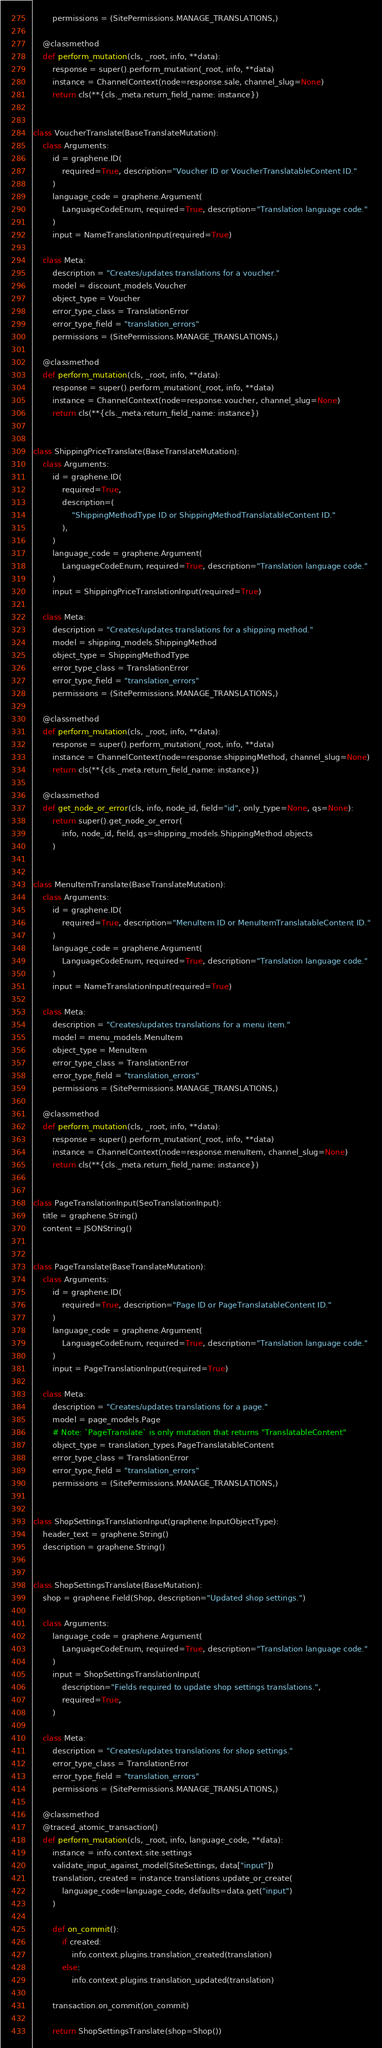Convert code to text. <code><loc_0><loc_0><loc_500><loc_500><_Python_>        permissions = (SitePermissions.MANAGE_TRANSLATIONS,)

    @classmethod
    def perform_mutation(cls, _root, info, **data):
        response = super().perform_mutation(_root, info, **data)
        instance = ChannelContext(node=response.sale, channel_slug=None)
        return cls(**{cls._meta.return_field_name: instance})


class VoucherTranslate(BaseTranslateMutation):
    class Arguments:
        id = graphene.ID(
            required=True, description="Voucher ID or VoucherTranslatableContent ID."
        )
        language_code = graphene.Argument(
            LanguageCodeEnum, required=True, description="Translation language code."
        )
        input = NameTranslationInput(required=True)

    class Meta:
        description = "Creates/updates translations for a voucher."
        model = discount_models.Voucher
        object_type = Voucher
        error_type_class = TranslationError
        error_type_field = "translation_errors"
        permissions = (SitePermissions.MANAGE_TRANSLATIONS,)

    @classmethod
    def perform_mutation(cls, _root, info, **data):
        response = super().perform_mutation(_root, info, **data)
        instance = ChannelContext(node=response.voucher, channel_slug=None)
        return cls(**{cls._meta.return_field_name: instance})


class ShippingPriceTranslate(BaseTranslateMutation):
    class Arguments:
        id = graphene.ID(
            required=True,
            description=(
                "ShippingMethodType ID or ShippingMethodTranslatableContent ID."
            ),
        )
        language_code = graphene.Argument(
            LanguageCodeEnum, required=True, description="Translation language code."
        )
        input = ShippingPriceTranslationInput(required=True)

    class Meta:
        description = "Creates/updates translations for a shipping method."
        model = shipping_models.ShippingMethod
        object_type = ShippingMethodType
        error_type_class = TranslationError
        error_type_field = "translation_errors"
        permissions = (SitePermissions.MANAGE_TRANSLATIONS,)

    @classmethod
    def perform_mutation(cls, _root, info, **data):
        response = super().perform_mutation(_root, info, **data)
        instance = ChannelContext(node=response.shippingMethod, channel_slug=None)
        return cls(**{cls._meta.return_field_name: instance})

    @classmethod
    def get_node_or_error(cls, info, node_id, field="id", only_type=None, qs=None):
        return super().get_node_or_error(
            info, node_id, field, qs=shipping_models.ShippingMethod.objects
        )


class MenuItemTranslate(BaseTranslateMutation):
    class Arguments:
        id = graphene.ID(
            required=True, description="MenuItem ID or MenuItemTranslatableContent ID."
        )
        language_code = graphene.Argument(
            LanguageCodeEnum, required=True, description="Translation language code."
        )
        input = NameTranslationInput(required=True)

    class Meta:
        description = "Creates/updates translations for a menu item."
        model = menu_models.MenuItem
        object_type = MenuItem
        error_type_class = TranslationError
        error_type_field = "translation_errors"
        permissions = (SitePermissions.MANAGE_TRANSLATIONS,)

    @classmethod
    def perform_mutation(cls, _root, info, **data):
        response = super().perform_mutation(_root, info, **data)
        instance = ChannelContext(node=response.menuItem, channel_slug=None)
        return cls(**{cls._meta.return_field_name: instance})


class PageTranslationInput(SeoTranslationInput):
    title = graphene.String()
    content = JSONString()


class PageTranslate(BaseTranslateMutation):
    class Arguments:
        id = graphene.ID(
            required=True, description="Page ID or PageTranslatableContent ID."
        )
        language_code = graphene.Argument(
            LanguageCodeEnum, required=True, description="Translation language code."
        )
        input = PageTranslationInput(required=True)

    class Meta:
        description = "Creates/updates translations for a page."
        model = page_models.Page
        # Note: `PageTranslate` is only mutation that returns "TranslatableContent"
        object_type = translation_types.PageTranslatableContent
        error_type_class = TranslationError
        error_type_field = "translation_errors"
        permissions = (SitePermissions.MANAGE_TRANSLATIONS,)


class ShopSettingsTranslationInput(graphene.InputObjectType):
    header_text = graphene.String()
    description = graphene.String()


class ShopSettingsTranslate(BaseMutation):
    shop = graphene.Field(Shop, description="Updated shop settings.")

    class Arguments:
        language_code = graphene.Argument(
            LanguageCodeEnum, required=True, description="Translation language code."
        )
        input = ShopSettingsTranslationInput(
            description="Fields required to update shop settings translations.",
            required=True,
        )

    class Meta:
        description = "Creates/updates translations for shop settings."
        error_type_class = TranslationError
        error_type_field = "translation_errors"
        permissions = (SitePermissions.MANAGE_TRANSLATIONS,)

    @classmethod
    @traced_atomic_transaction()
    def perform_mutation(cls, _root, info, language_code, **data):
        instance = info.context.site.settings
        validate_input_against_model(SiteSettings, data["input"])
        translation, created = instance.translations.update_or_create(
            language_code=language_code, defaults=data.get("input")
        )

        def on_commit():
            if created:
                info.context.plugins.translation_created(translation)
            else:
                info.context.plugins.translation_updated(translation)

        transaction.on_commit(on_commit)

        return ShopSettingsTranslate(shop=Shop())
</code> 